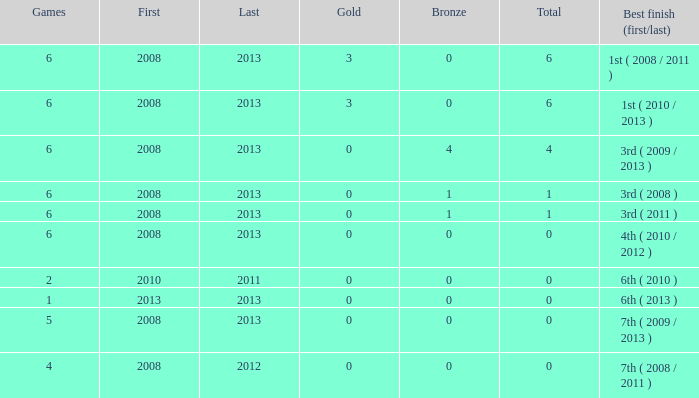How many bronzes related to greater than 0 total medals, 3 golds, and over 6 games? None. 